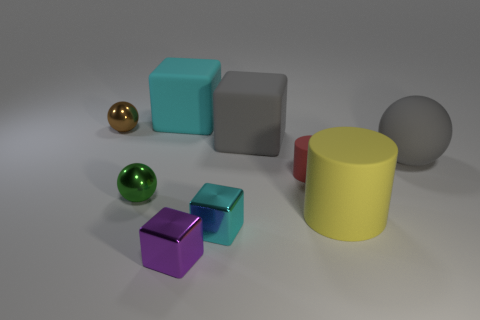There is a big gray thing that is to the left of the yellow thing; are there any metallic cubes on the left side of it?
Your answer should be compact. Yes. How many other objects are the same shape as the purple object?
Your response must be concise. 3. Is the tiny red rubber object the same shape as the yellow object?
Make the answer very short. Yes. There is a small object that is behind the tiny green object and on the right side of the big cyan object; what is its color?
Your response must be concise. Red. The object that is the same color as the large rubber sphere is what size?
Your answer should be compact. Large. How many big objects are blue metal cylinders or cyan rubber things?
Provide a succinct answer. 1. Is there any other thing of the same color as the big rubber ball?
Give a very brief answer. Yes. What material is the sphere to the right of the cyan block that is behind the small sphere that is behind the gray ball made of?
Offer a terse response. Rubber. What number of metallic things are either tiny cyan objects or small brown things?
Your response must be concise. 2. What number of yellow objects are either large metal spheres or large matte balls?
Keep it short and to the point. 0. 